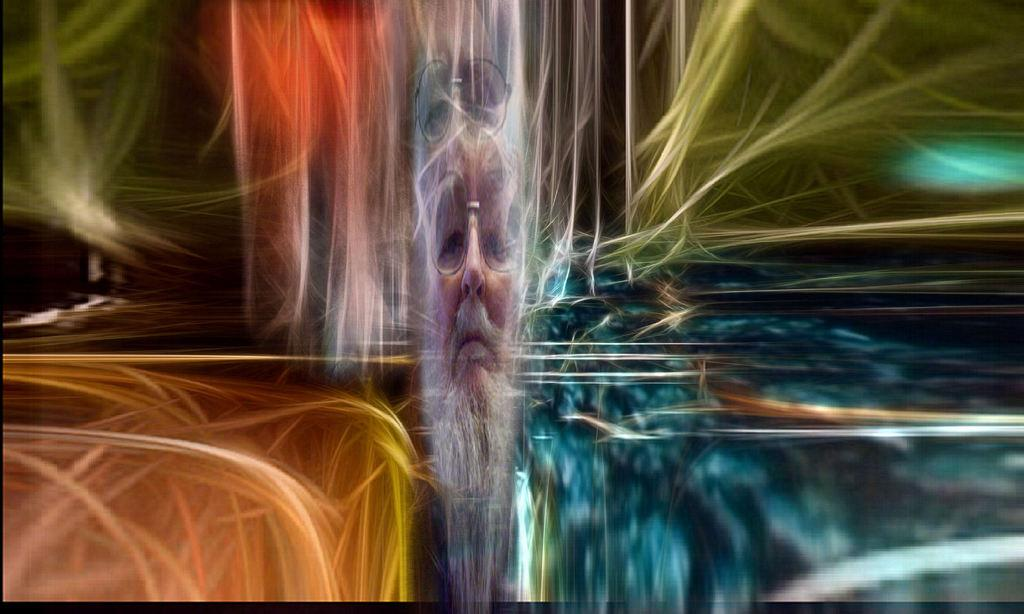What type of image is being described? The image is an edited picture. What is the main subject of the image? There is a person's face in the middle of the image. How would you describe the appearance of the image? The picture consists of various colors of light. What type of advice is the person in the image giving? There is no indication in the image that the person is giving any advice. Is there a drawer visible in the image? No, there is no drawer present in the image. 